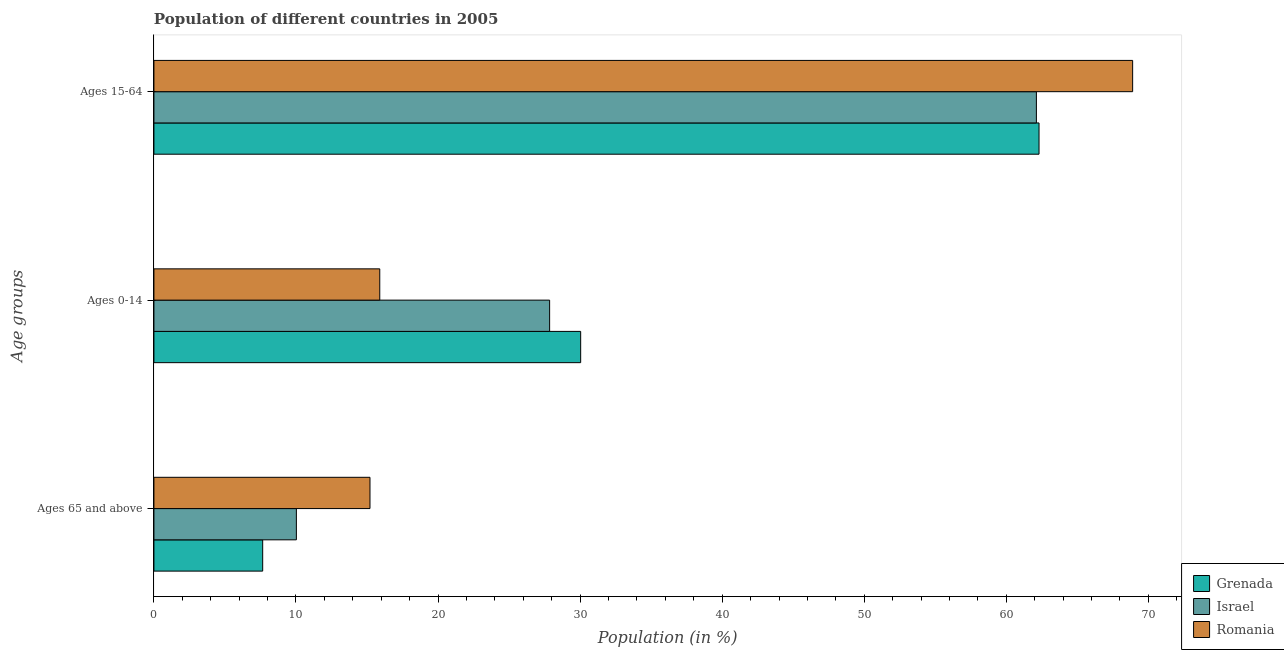Are the number of bars on each tick of the Y-axis equal?
Give a very brief answer. Yes. How many bars are there on the 1st tick from the top?
Provide a succinct answer. 3. What is the label of the 3rd group of bars from the top?
Make the answer very short. Ages 65 and above. What is the percentage of population within the age-group of 65 and above in Israel?
Your answer should be compact. 10.03. Across all countries, what is the maximum percentage of population within the age-group 15-64?
Offer a terse response. 68.89. Across all countries, what is the minimum percentage of population within the age-group of 65 and above?
Keep it short and to the point. 7.66. In which country was the percentage of population within the age-group of 65 and above maximum?
Your answer should be very brief. Romania. In which country was the percentage of population within the age-group 15-64 minimum?
Your response must be concise. Israel. What is the total percentage of population within the age-group of 65 and above in the graph?
Your answer should be very brief. 32.89. What is the difference between the percentage of population within the age-group of 65 and above in Grenada and that in Romania?
Offer a very short reply. -7.55. What is the difference between the percentage of population within the age-group of 65 and above in Romania and the percentage of population within the age-group 0-14 in Grenada?
Offer a terse response. -14.83. What is the average percentage of population within the age-group 15-64 per country?
Give a very brief answer. 64.44. What is the difference between the percentage of population within the age-group 0-14 and percentage of population within the age-group of 65 and above in Romania?
Ensure brevity in your answer.  0.69. In how many countries, is the percentage of population within the age-group 0-14 greater than 48 %?
Ensure brevity in your answer.  0. What is the ratio of the percentage of population within the age-group of 65 and above in Israel to that in Romania?
Your answer should be compact. 0.66. Is the percentage of population within the age-group 15-64 in Grenada less than that in Romania?
Provide a short and direct response. Yes. What is the difference between the highest and the second highest percentage of population within the age-group of 65 and above?
Give a very brief answer. 5.18. What is the difference between the highest and the lowest percentage of population within the age-group 15-64?
Offer a terse response. 6.77. In how many countries, is the percentage of population within the age-group of 65 and above greater than the average percentage of population within the age-group of 65 and above taken over all countries?
Ensure brevity in your answer.  1. Is the sum of the percentage of population within the age-group 0-14 in Romania and Grenada greater than the maximum percentage of population within the age-group of 65 and above across all countries?
Provide a succinct answer. Yes. What does the 3rd bar from the bottom in Ages 65 and above represents?
Make the answer very short. Romania. Is it the case that in every country, the sum of the percentage of population within the age-group of 65 and above and percentage of population within the age-group 0-14 is greater than the percentage of population within the age-group 15-64?
Your response must be concise. No. Are all the bars in the graph horizontal?
Make the answer very short. Yes. What is the difference between two consecutive major ticks on the X-axis?
Make the answer very short. 10. Does the graph contain grids?
Keep it short and to the point. No. What is the title of the graph?
Your answer should be compact. Population of different countries in 2005. What is the label or title of the Y-axis?
Give a very brief answer. Age groups. What is the Population (in %) of Grenada in Ages 65 and above?
Your answer should be very brief. 7.66. What is the Population (in %) in Israel in Ages 65 and above?
Your answer should be compact. 10.03. What is the Population (in %) of Romania in Ages 65 and above?
Your response must be concise. 15.21. What is the Population (in %) in Grenada in Ages 0-14?
Offer a terse response. 30.04. What is the Population (in %) in Israel in Ages 0-14?
Make the answer very short. 27.85. What is the Population (in %) in Romania in Ages 0-14?
Your answer should be very brief. 15.9. What is the Population (in %) in Grenada in Ages 15-64?
Ensure brevity in your answer.  62.3. What is the Population (in %) in Israel in Ages 15-64?
Offer a terse response. 62.12. What is the Population (in %) of Romania in Ages 15-64?
Give a very brief answer. 68.89. Across all Age groups, what is the maximum Population (in %) in Grenada?
Your answer should be very brief. 62.3. Across all Age groups, what is the maximum Population (in %) of Israel?
Give a very brief answer. 62.12. Across all Age groups, what is the maximum Population (in %) in Romania?
Ensure brevity in your answer.  68.89. Across all Age groups, what is the minimum Population (in %) of Grenada?
Keep it short and to the point. 7.66. Across all Age groups, what is the minimum Population (in %) of Israel?
Offer a very short reply. 10.03. Across all Age groups, what is the minimum Population (in %) of Romania?
Ensure brevity in your answer.  15.21. What is the total Population (in %) of Romania in the graph?
Offer a very short reply. 100. What is the difference between the Population (in %) of Grenada in Ages 65 and above and that in Ages 0-14?
Give a very brief answer. -22.38. What is the difference between the Population (in %) in Israel in Ages 65 and above and that in Ages 0-14?
Your answer should be compact. -17.83. What is the difference between the Population (in %) of Romania in Ages 65 and above and that in Ages 0-14?
Offer a very short reply. -0.69. What is the difference between the Population (in %) in Grenada in Ages 65 and above and that in Ages 15-64?
Your answer should be very brief. -54.65. What is the difference between the Population (in %) of Israel in Ages 65 and above and that in Ages 15-64?
Your answer should be compact. -52.09. What is the difference between the Population (in %) in Romania in Ages 65 and above and that in Ages 15-64?
Offer a terse response. -53.68. What is the difference between the Population (in %) of Grenada in Ages 0-14 and that in Ages 15-64?
Ensure brevity in your answer.  -32.26. What is the difference between the Population (in %) in Israel in Ages 0-14 and that in Ages 15-64?
Make the answer very short. -34.26. What is the difference between the Population (in %) of Romania in Ages 0-14 and that in Ages 15-64?
Offer a terse response. -53. What is the difference between the Population (in %) of Grenada in Ages 65 and above and the Population (in %) of Israel in Ages 0-14?
Give a very brief answer. -20.2. What is the difference between the Population (in %) of Grenada in Ages 65 and above and the Population (in %) of Romania in Ages 0-14?
Your response must be concise. -8.24. What is the difference between the Population (in %) of Israel in Ages 65 and above and the Population (in %) of Romania in Ages 0-14?
Provide a succinct answer. -5.87. What is the difference between the Population (in %) of Grenada in Ages 65 and above and the Population (in %) of Israel in Ages 15-64?
Ensure brevity in your answer.  -54.46. What is the difference between the Population (in %) in Grenada in Ages 65 and above and the Population (in %) in Romania in Ages 15-64?
Offer a very short reply. -61.24. What is the difference between the Population (in %) in Israel in Ages 65 and above and the Population (in %) in Romania in Ages 15-64?
Make the answer very short. -58.87. What is the difference between the Population (in %) of Grenada in Ages 0-14 and the Population (in %) of Israel in Ages 15-64?
Your answer should be very brief. -32.08. What is the difference between the Population (in %) in Grenada in Ages 0-14 and the Population (in %) in Romania in Ages 15-64?
Keep it short and to the point. -38.85. What is the difference between the Population (in %) of Israel in Ages 0-14 and the Population (in %) of Romania in Ages 15-64?
Your answer should be very brief. -41.04. What is the average Population (in %) in Grenada per Age groups?
Provide a succinct answer. 33.33. What is the average Population (in %) of Israel per Age groups?
Offer a very short reply. 33.33. What is the average Population (in %) of Romania per Age groups?
Your answer should be compact. 33.33. What is the difference between the Population (in %) in Grenada and Population (in %) in Israel in Ages 65 and above?
Give a very brief answer. -2.37. What is the difference between the Population (in %) in Grenada and Population (in %) in Romania in Ages 65 and above?
Make the answer very short. -7.55. What is the difference between the Population (in %) of Israel and Population (in %) of Romania in Ages 65 and above?
Offer a terse response. -5.18. What is the difference between the Population (in %) of Grenada and Population (in %) of Israel in Ages 0-14?
Your answer should be very brief. 2.19. What is the difference between the Population (in %) in Grenada and Population (in %) in Romania in Ages 0-14?
Make the answer very short. 14.14. What is the difference between the Population (in %) of Israel and Population (in %) of Romania in Ages 0-14?
Offer a terse response. 11.96. What is the difference between the Population (in %) of Grenada and Population (in %) of Israel in Ages 15-64?
Offer a very short reply. 0.19. What is the difference between the Population (in %) of Grenada and Population (in %) of Romania in Ages 15-64?
Provide a succinct answer. -6.59. What is the difference between the Population (in %) of Israel and Population (in %) of Romania in Ages 15-64?
Ensure brevity in your answer.  -6.77. What is the ratio of the Population (in %) of Grenada in Ages 65 and above to that in Ages 0-14?
Offer a very short reply. 0.25. What is the ratio of the Population (in %) of Israel in Ages 65 and above to that in Ages 0-14?
Keep it short and to the point. 0.36. What is the ratio of the Population (in %) in Romania in Ages 65 and above to that in Ages 0-14?
Keep it short and to the point. 0.96. What is the ratio of the Population (in %) in Grenada in Ages 65 and above to that in Ages 15-64?
Ensure brevity in your answer.  0.12. What is the ratio of the Population (in %) in Israel in Ages 65 and above to that in Ages 15-64?
Provide a succinct answer. 0.16. What is the ratio of the Population (in %) in Romania in Ages 65 and above to that in Ages 15-64?
Ensure brevity in your answer.  0.22. What is the ratio of the Population (in %) in Grenada in Ages 0-14 to that in Ages 15-64?
Give a very brief answer. 0.48. What is the ratio of the Population (in %) in Israel in Ages 0-14 to that in Ages 15-64?
Provide a short and direct response. 0.45. What is the ratio of the Population (in %) of Romania in Ages 0-14 to that in Ages 15-64?
Your answer should be compact. 0.23. What is the difference between the highest and the second highest Population (in %) in Grenada?
Provide a short and direct response. 32.26. What is the difference between the highest and the second highest Population (in %) of Israel?
Keep it short and to the point. 34.26. What is the difference between the highest and the second highest Population (in %) in Romania?
Your response must be concise. 53. What is the difference between the highest and the lowest Population (in %) in Grenada?
Provide a succinct answer. 54.65. What is the difference between the highest and the lowest Population (in %) in Israel?
Provide a short and direct response. 52.09. What is the difference between the highest and the lowest Population (in %) in Romania?
Give a very brief answer. 53.68. 